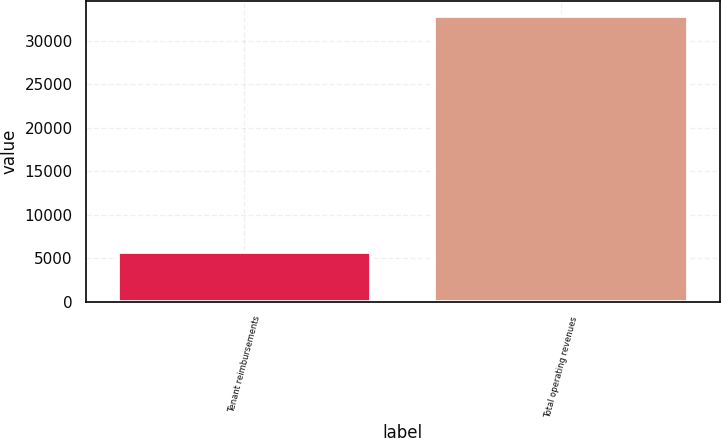<chart> <loc_0><loc_0><loc_500><loc_500><bar_chart><fcel>Tenant reimbursements<fcel>Total operating revenues<nl><fcel>5716<fcel>32895<nl></chart> 